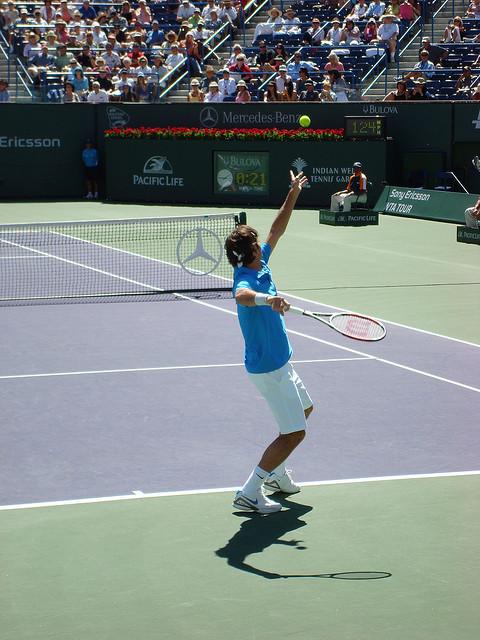Is this man working for Mercedes Benz?
Quick response, please. No. Is the tennis player returning the ball?
Give a very brief answer. Yes. What is the man doing to the ball?
Keep it brief. Serving. What color is his shirt?
Keep it brief. Blue. 